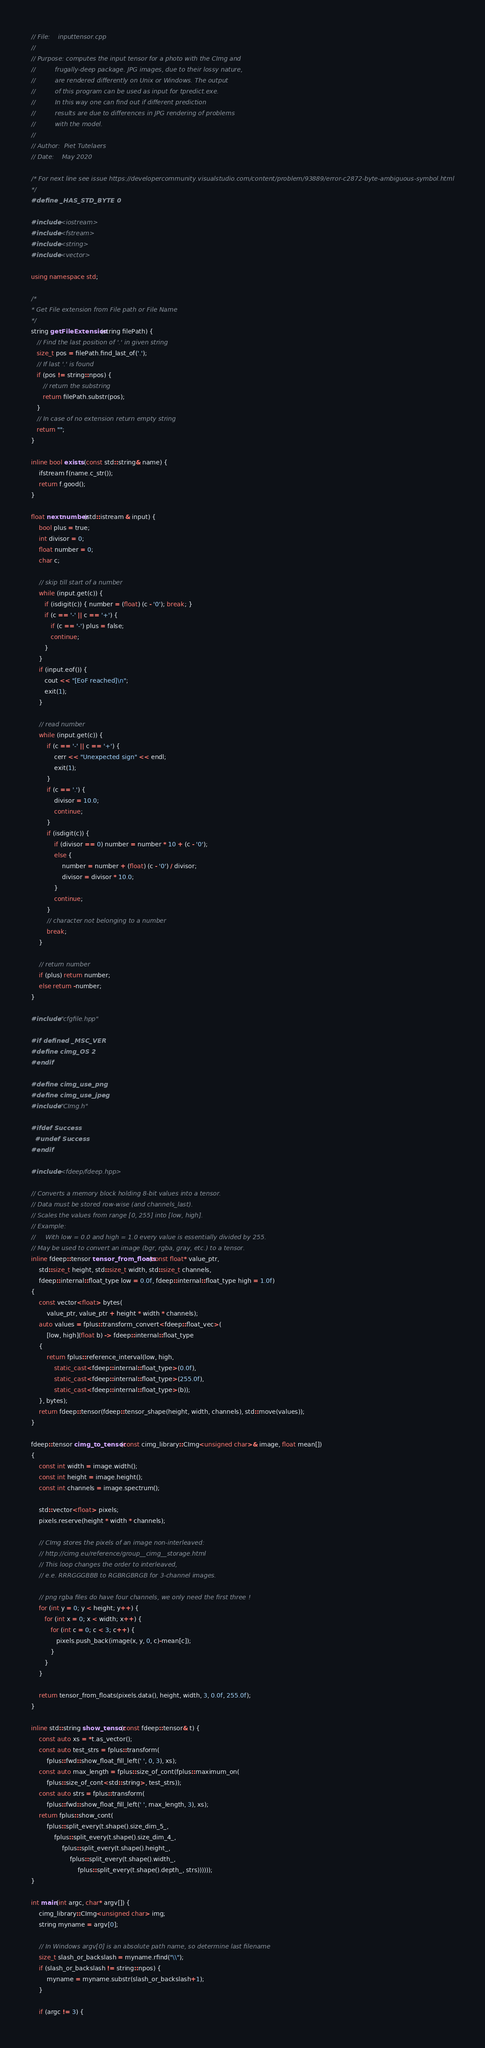<code> <loc_0><loc_0><loc_500><loc_500><_C++_>// File:    inputtensor.cpp
//
// Purpose: computes the input tensor for a photo with the CImg and
//			frugally-deep package. JPG images, due to their lossy nature,
//			are rendered differently on Unix or Windows. The output
//		 	of this program can be used as input for tpredict.exe.
//          In this way one can find out if different prediction
//			results are due to differences in JPG rendering of problems
//			with the model.
//
// Author:  Piet Tutelaers
// Date:    May 2020

/* For next line see issue https://developercommunity.visualstudio.com/content/problem/93889/error-c2872-byte-ambiguous-symbol.html
*/
#define _HAS_STD_BYTE 0

#include <iostream>
#include <fstream>
#include <string>
#include <vector>

using namespace std;

/*
* Get File extension from File path or File Name
*/
string getFileExtension(string filePath) {
   // Find the last position of '.' in given string
   size_t pos = filePath.find_last_of('.');
   // If last '.' is found
   if (pos != string::npos) {
      // return the substring
      return filePath.substr(pos);
   }
   // In case of no extension return empty string
   return "";
}

inline bool exists (const std::string& name) {
    ifstream f(name.c_str());
    return f.good();
}

float nextnumber(std::istream & input) {
	bool plus = true;
	int divisor = 0;
    float number = 0; 
    char c;

    // skip till start of a number
    while (input.get(c)) {
       if (isdigit(c)) { number = (float) (c - '0'); break; }
	   if (c == '-' || c == '+') {
		  if (c == '-') plus = false;
		  continue;
	   }
	}
	if (input.eof()) {
	   cout << "[EoF reached]\n";
	   exit(1);
	}
	
    // read number
    while (input.get(c)) {
		if (c == '-' || c == '+') {
			cerr << "Unexpected sign" << endl;
			exit(1);
		}
		if (c == '.') {
			divisor = 10.0;
			continue;
		}
		if (isdigit(c)) {
			if (divisor == 0) number = number * 10 + (c - '0');
			else {
				number = number + (float) (c - '0') / divisor;
				divisor = divisor * 10.0;
			}
			continue;
		}
        // character not belonging to a number
		break;
    }

    // return number
    if (plus) return number;
	else return -number;
}

#include "cfgfile.hpp"

#if defined _MSC_VER
#define cimg_OS 2
#endif

#define cimg_use_png
#define cimg_use_jpeg
#include "CImg.h"

#ifdef Success
  #undef Success
#endif

#include <fdeep/fdeep.hpp>

// Converts a memory block holding 8-bit values into a tensor.
// Data must be stored row-wise (and channels_last).
// Scales the values from range [0, 255] into [low, high].
// Example:
//     With low = 0.0 and high = 1.0 every value is essentially divided by 255.
// May be used to convert an image (bgr, rgba, gray, etc.) to a tensor.
inline fdeep::tensor tensor_from_floats(const float* value_ptr,
    std::size_t height, std::size_t width, std::size_t channels,
    fdeep::internal::float_type low = 0.0f, fdeep::internal::float_type high = 1.0f)
{
    const vector<float> bytes(
        value_ptr, value_ptr + height * width * channels);
    auto values = fplus::transform_convert<fdeep::float_vec>(
        [low, high](float b) -> fdeep::internal::float_type
    {
        return fplus::reference_interval(low, high,
            static_cast<fdeep::internal::float_type>(0.0f),
            static_cast<fdeep::internal::float_type>(255.0f),
            static_cast<fdeep::internal::float_type>(b));
    }, bytes);
    return fdeep::tensor(fdeep::tensor_shape(height, width, channels), std::move(values));
}

fdeep::tensor cimg_to_tensor(const cimg_library::CImg<unsigned char>& image, float mean[])
{
    const int width = image.width();
    const int height = image.height();
    const int channels = image.spectrum();

    std::vector<float> pixels;
    pixels.reserve(height * width * channels);

    // CImg stores the pixels of an image non-interleaved:
    // http://cimg.eu/reference/group__cimg__storage.html
    // This loop changes the order to interleaved,
    // e.e. RRRGGGBBB to RGBRGBRGB for 3-channel images.
	
	// png rgba files do have four channels, we only need the first three !
    for (int y = 0; y < height; y++) {
       for (int x = 0; x < width; x++) {
          for (int c = 0; c < 3; c++) {
             pixels.push_back(image(x, y, 0, c)-mean[c]);
          }
       }
    }

    return tensor_from_floats(pixels.data(), height, width, 3, 0.0f, 255.0f);
}

inline std::string show_tensor(const fdeep::tensor& t) {
    const auto xs = *t.as_vector();
    const auto test_strs = fplus::transform(
        fplus::fwd::show_float_fill_left(' ', 0, 3), xs);
    const auto max_length = fplus::size_of_cont(fplus::maximum_on(
        fplus::size_of_cont<std::string>, test_strs));
    const auto strs = fplus::transform(
        fplus::fwd::show_float_fill_left(' ', max_length, 3), xs);
    return fplus::show_cont(
        fplus::split_every(t.shape().size_dim_5_,
            fplus::split_every(t.shape().size_dim_4_,
                fplus::split_every(t.shape().height_,
                    fplus::split_every(t.shape().width_,
                        fplus::split_every(t.shape().depth_, strs))))));
}

int main(int argc, char* argv[]) {
    cimg_library::CImg<unsigned char> img;
	string myname = argv[0];
	
    // In Windows argv[0] is an absolute path name, so determine last filename
    size_t slash_or_backslash = myname.rfind("\\");
    if (slash_or_backslash != string::npos) {
        myname = myname.substr(slash_or_backslash+1);
    }

	if (argc != 3) {</code> 